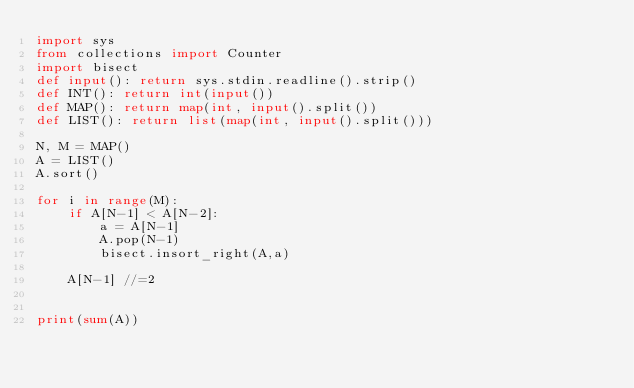<code> <loc_0><loc_0><loc_500><loc_500><_Python_>import sys
from collections import Counter
import bisect
def input(): return sys.stdin.readline().strip()
def INT(): return int(input())
def MAP(): return map(int, input().split())
def LIST(): return list(map(int, input().split()))

N, M = MAP()
A = LIST()
A.sort()

for i in range(M):
    if A[N-1] < A[N-2]:
        a = A[N-1]
        A.pop(N-1)
        bisect.insort_right(A,a)

    A[N-1] //=2


print(sum(A))

    </code> 